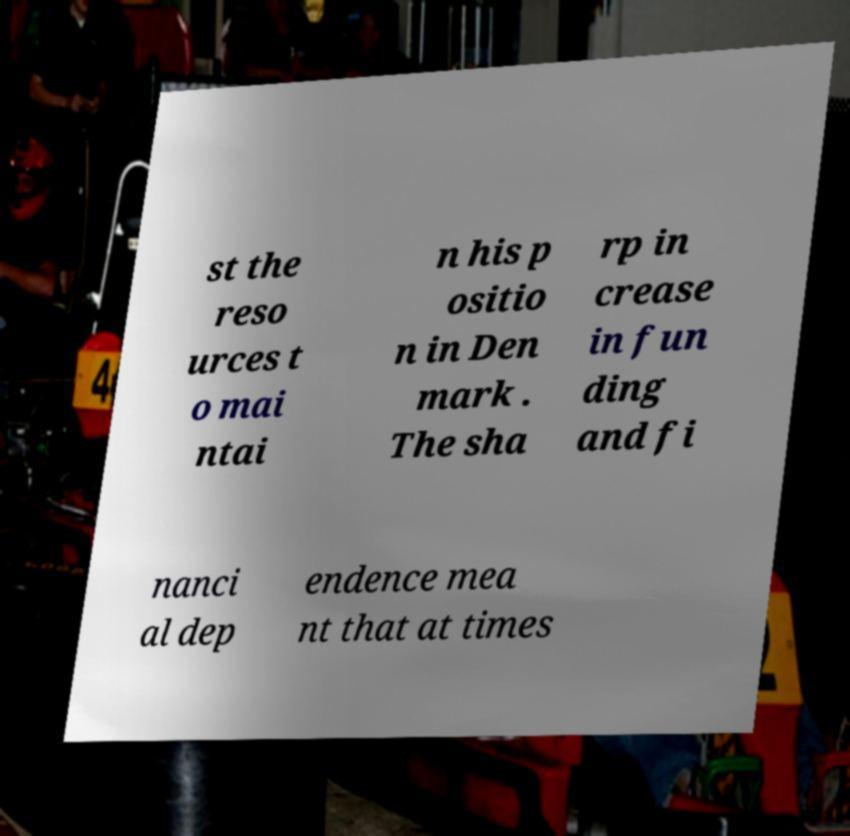Please identify and transcribe the text found in this image. st the reso urces t o mai ntai n his p ositio n in Den mark . The sha rp in crease in fun ding and fi nanci al dep endence mea nt that at times 